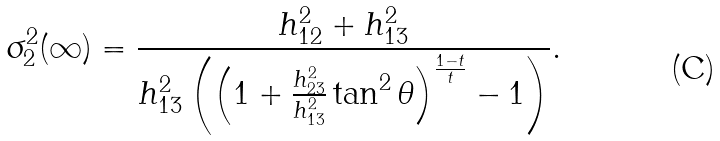<formula> <loc_0><loc_0><loc_500><loc_500>\sigma _ { 2 } ^ { 2 } ( \infty ) = \frac { h _ { 1 2 } ^ { 2 } + h _ { 1 3 } ^ { 2 } } { h _ { 1 3 } ^ { 2 } \left ( \left ( 1 + \frac { h _ { 2 3 } ^ { 2 } } { h _ { 1 3 } ^ { 2 } } \tan ^ { 2 } \theta \right ) ^ { \frac { 1 - t } { t } } - 1 \right ) } .</formula> 